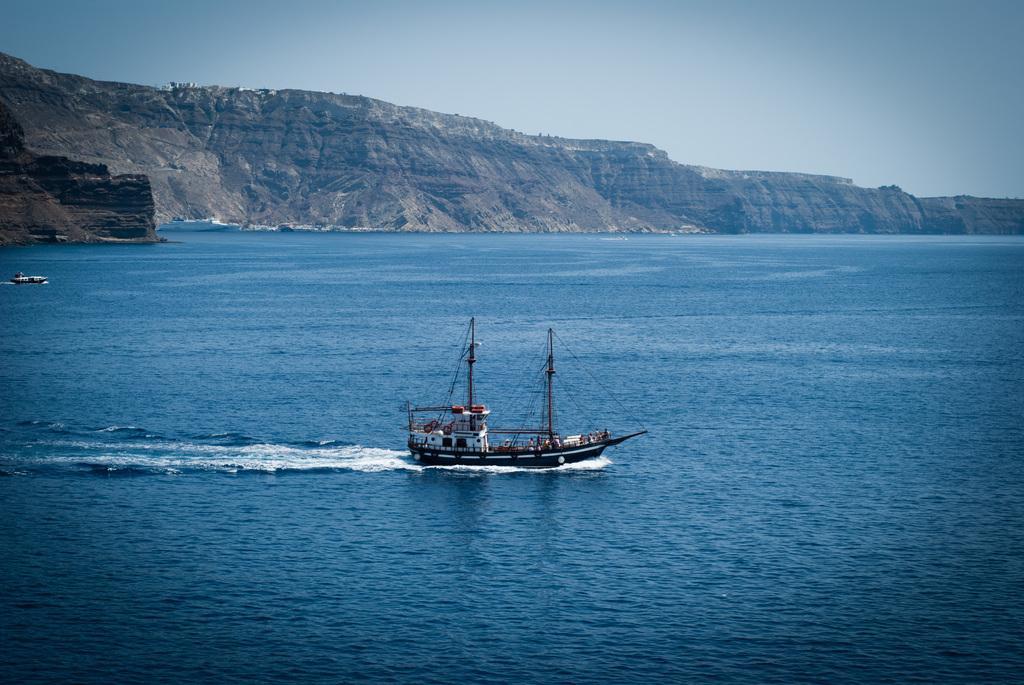Please provide a concise description of this image. In this image there is a boat in the water. In the background there are hills. At the top there is the sky. 